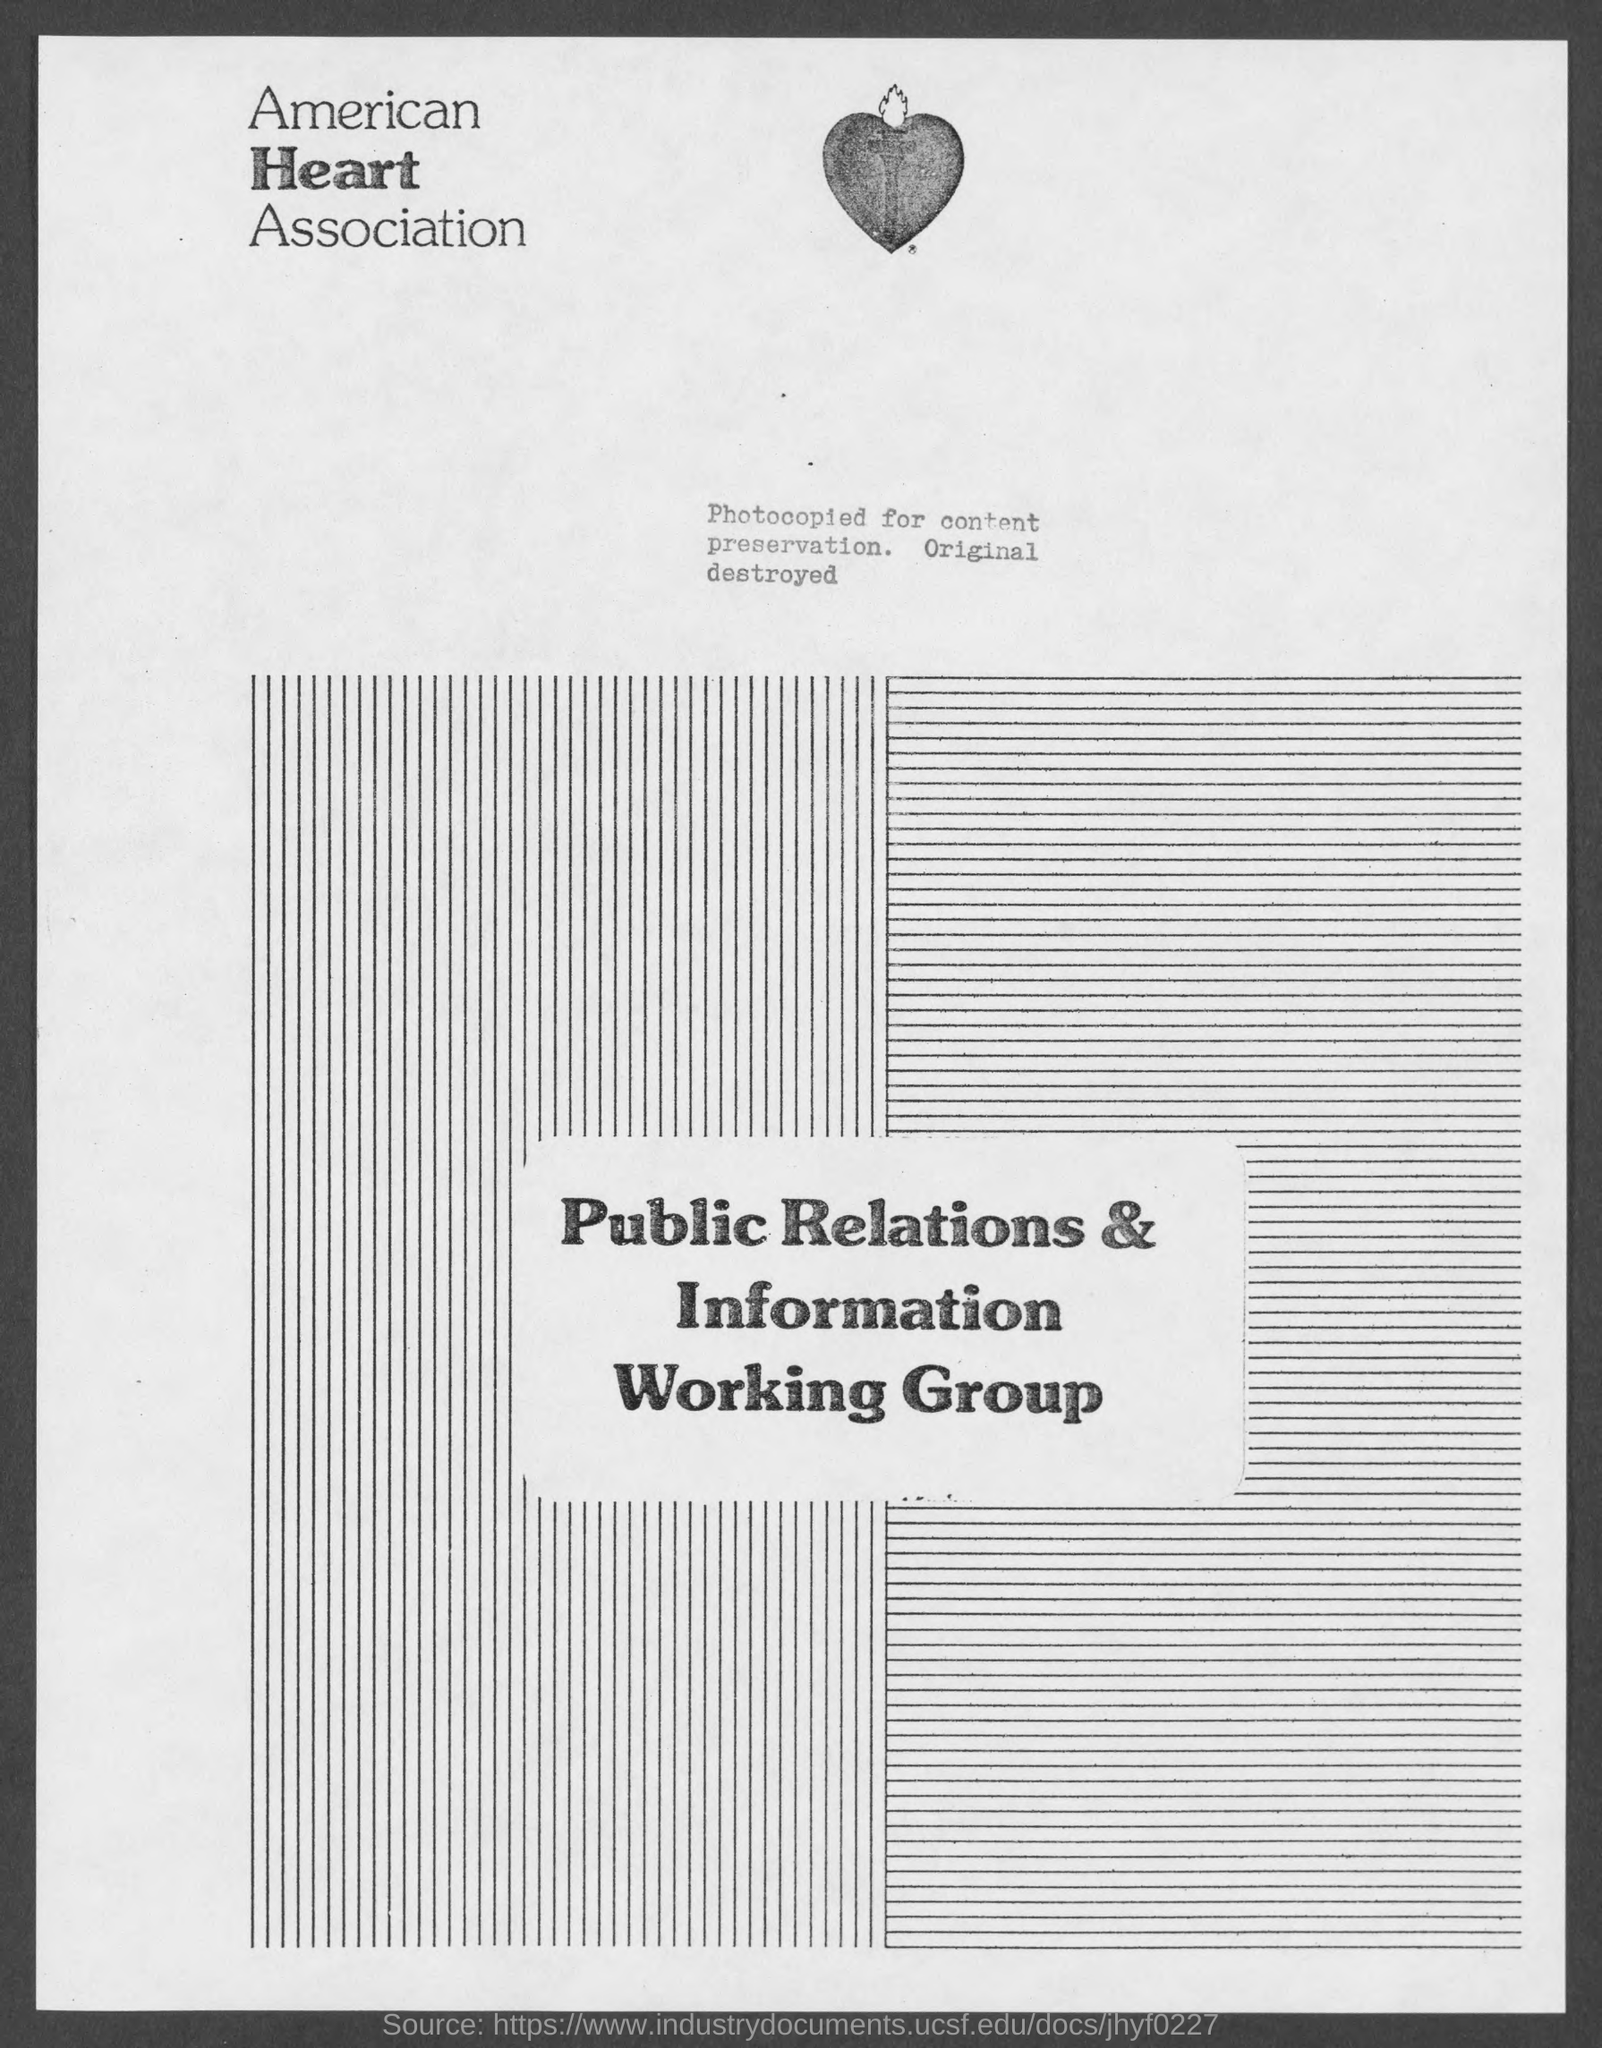Outline some significant characteristics in this image. The American Heart Association is the name of the association mentioned in the given page. 